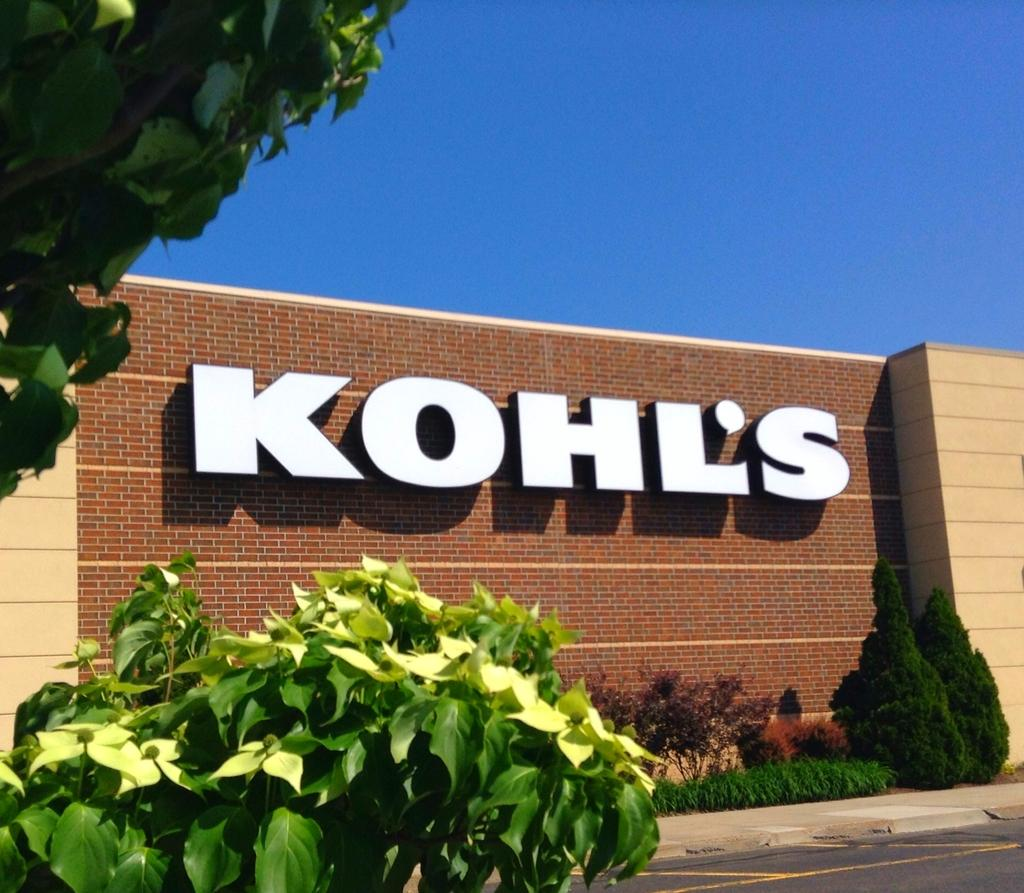What is written or displayed on the wall in the image? There is text on the wall in the image. What type of vegetation can be seen in the image? There are plants and trees in the image. What color is the sky in the image? The sky is blue in the image. What song is being sung by the plants in the image? There are no plants singing in the image; they are stationary vegetation. How does the presence of trees in the image lead to an increase in oxygen levels? The image does not show any change in oxygen levels; it is a static representation of trees. 